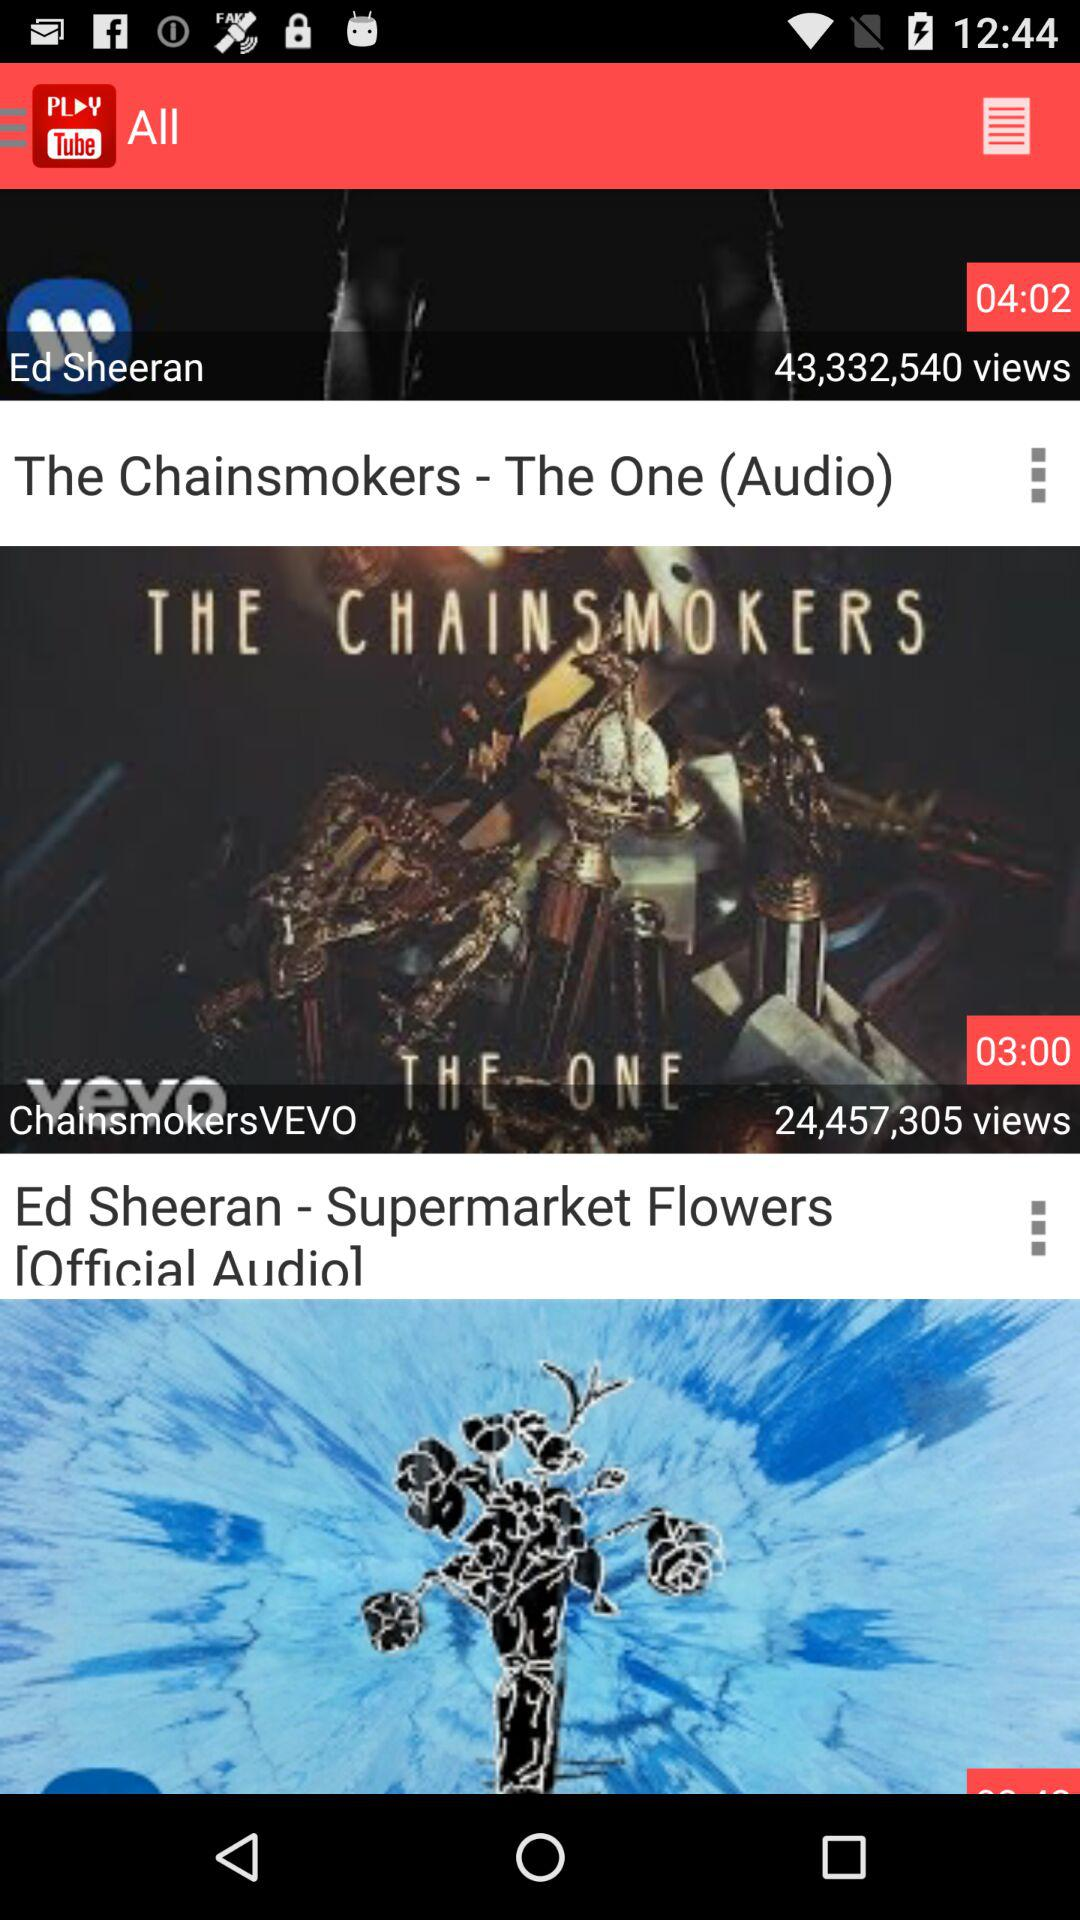How many more seconds is the video with the longest duration than the video with the shortest duration? The Chainsmokers' audio track 'The One' has a duration of 4 minutes and 2 seconds, while Ed Sheeran's audio track 'Supermarket Flowers' is 3 minutes long. This means the longest video exceeds the shortest one by 62 seconds. 